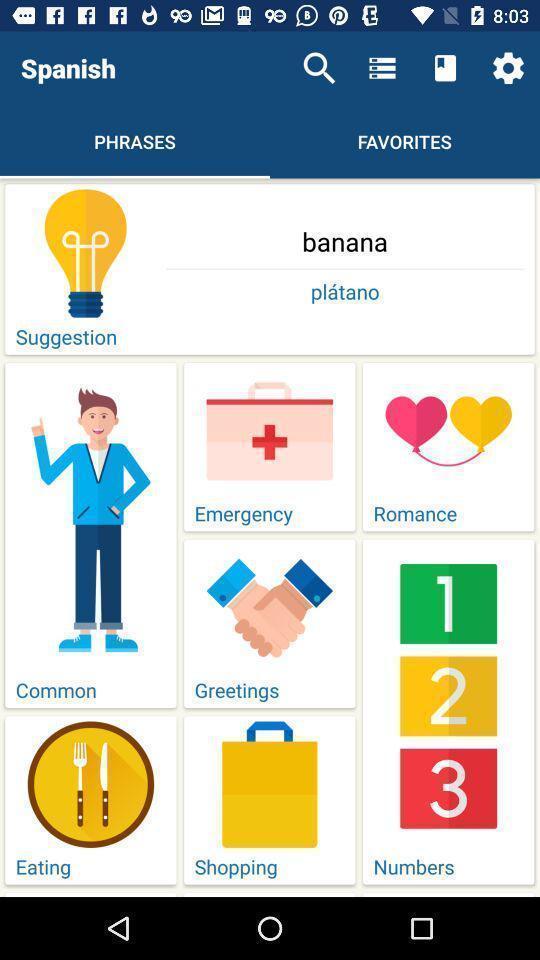Provide a textual representation of this image. Screen displaying spanish phrases on different topics. 